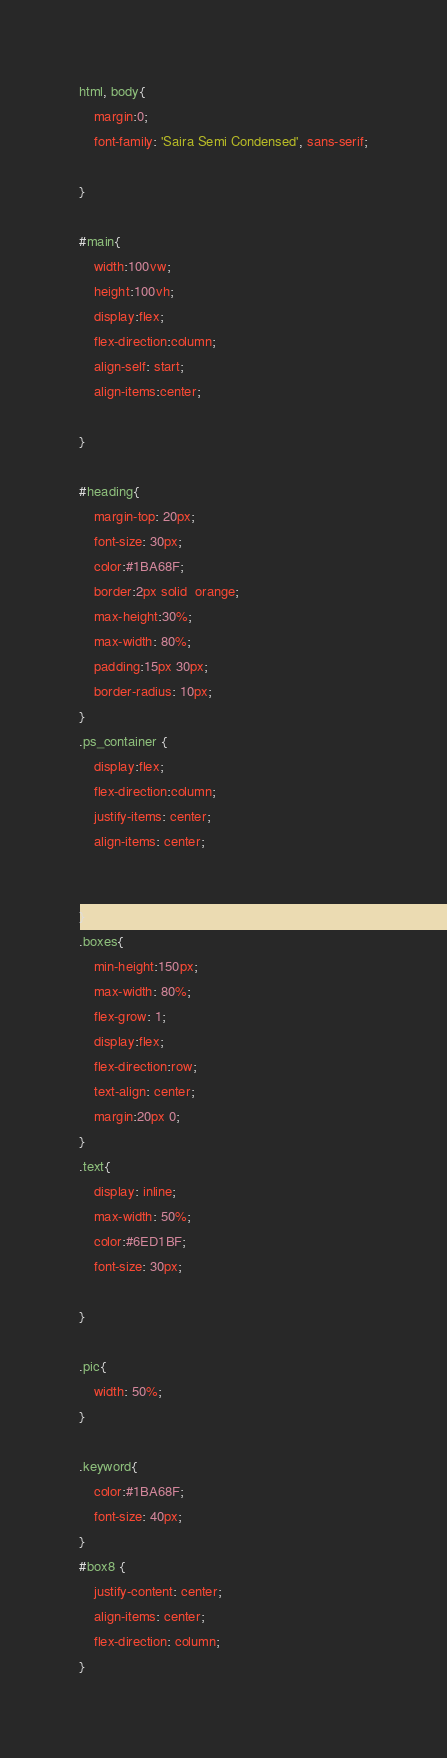<code> <loc_0><loc_0><loc_500><loc_500><_CSS_>html, body{
    margin:0;
    font-family: 'Saira Semi Condensed', sans-serif;

}

#main{
    width:100vw;
    height:100vh;
    display:flex;
    flex-direction:column;
    align-self: start;
    align-items:center;

}

#heading{
    margin-top: 20px;
    font-size: 30px;
    color:#1BA68F;
    border:2px solid  orange;
    max-height:30%;
    max-width: 80%;
    padding:15px 30px;
    border-radius: 10px;
}
.ps_container {
    display:flex;
    flex-direction:column;
    justify-items: center;
    align-items: center;
    
   
}
.boxes{
    min-height:150px;
    max-width: 80%;
    flex-grow: 1;
    display:flex;
    flex-direction:row;
    text-align: center;
    margin:20px 0;
}
.text{
    display: inline;
    max-width: 50%;
    color:#6ED1BF;
    font-size: 30px;
    
}

.pic{
    width: 50%;
}

.keyword{
    color:#1BA68F;
    font-size: 40px;
}
#box8 {
    justify-content: center;
    align-items: center;
    flex-direction: column;
}

</code> 